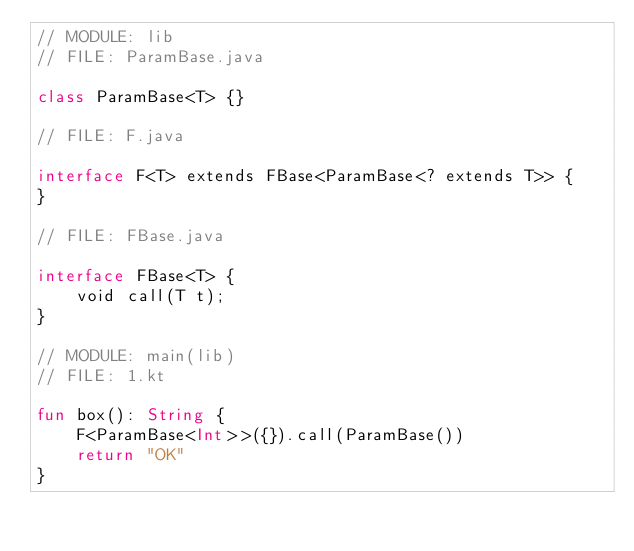<code> <loc_0><loc_0><loc_500><loc_500><_Kotlin_>// MODULE: lib
// FILE: ParamBase.java

class ParamBase<T> {}

// FILE: F.java

interface F<T> extends FBase<ParamBase<? extends T>> {
}

// FILE: FBase.java

interface FBase<T> {
    void call(T t);
}

// MODULE: main(lib)
// FILE: 1.kt

fun box(): String {
    F<ParamBase<Int>>({}).call(ParamBase())
    return "OK"
}
</code> 